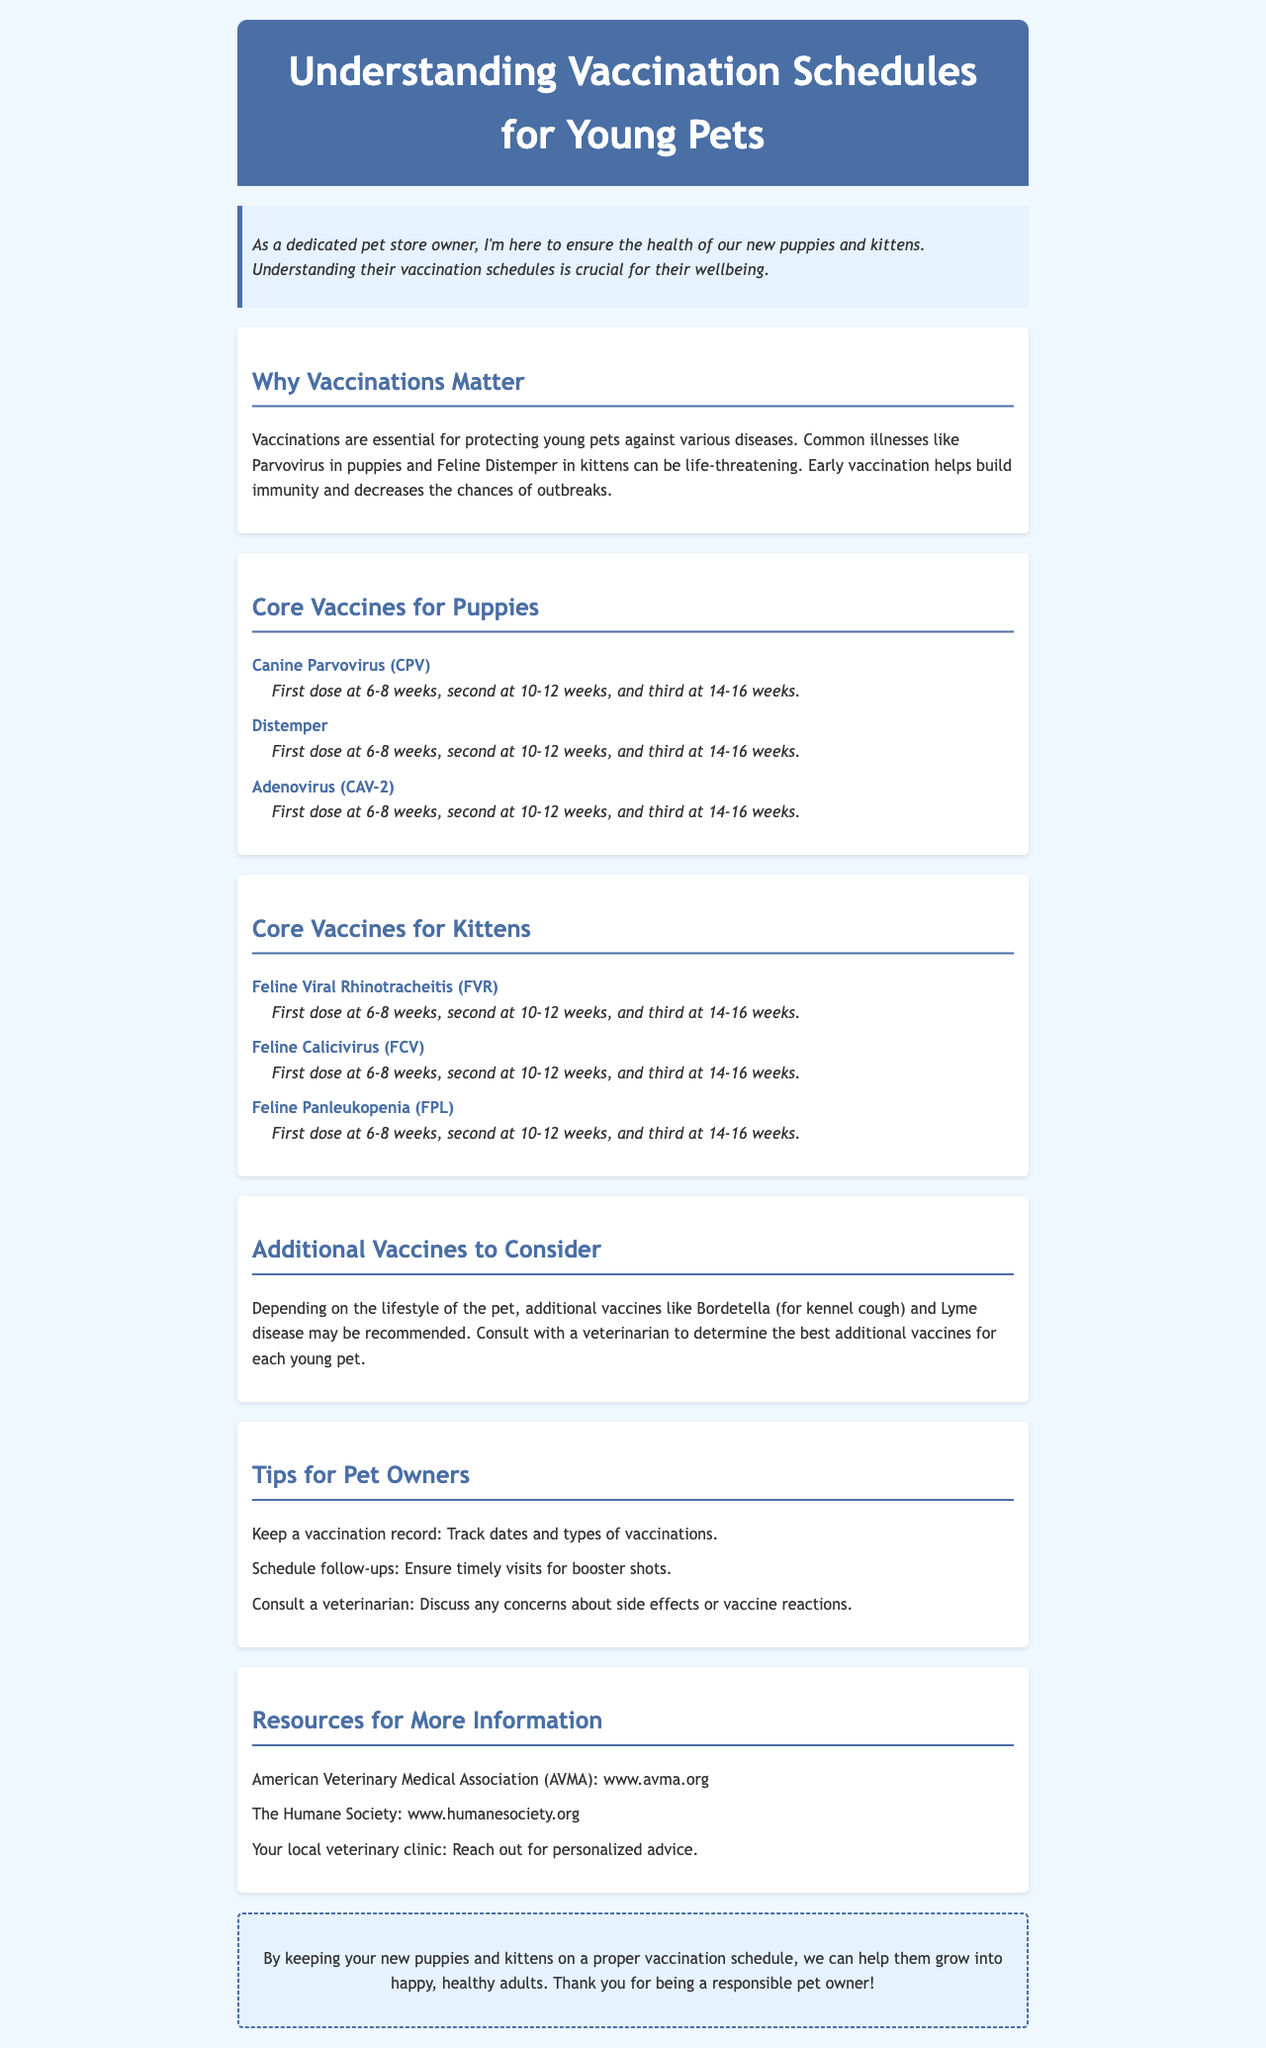What are the core vaccines for puppies? The core vaccines for puppies listed in the document are Canine Parvovirus, Distemper, and Adenovirus.
Answer: Canine Parvovirus, Distemper, Adenovirus What is the vaccination schedule for Feline Panleukopenia? The document mentions the vaccination schedule for Feline Panleukopenia as the first dose at 6-8 weeks, second at 10-12 weeks, and third at 14-16 weeks.
Answer: First dose at 6-8 weeks, second at 10-12 weeks, third at 14-16 weeks Why are vaccinations essential for young pets? The document states vaccinations are essential to protect young pets against various diseases, such as Parvovirus and Feline Distemper.
Answer: To protect against diseases What should pet owners keep track of regarding vaccinations? The document suggests that pet owners should keep a vaccination record to track dates and types of vaccinations.
Answer: A vaccination record How many doses are recommended for core vaccines for puppies? The schedule in the document indicates three doses are recommended for core vaccines for puppies.
Answer: Three doses Who should pets consult regarding additional vaccines? The document advises consulting a veterinarian to determine the best additional vaccines for each young pet.
Answer: A veterinarian What organization provides more information on pet vaccinations? The American Veterinary Medical Association (AVMA) is mentioned in the document as a resource for more information.
Answer: American Veterinary Medical Association (AVMA) What is the theme of the closing message in the newsletter? The closing message emphasizes the importance of keeping puppies and kittens healthy through proper vaccination schedules.
Answer: Importance of health through vaccination schedules 